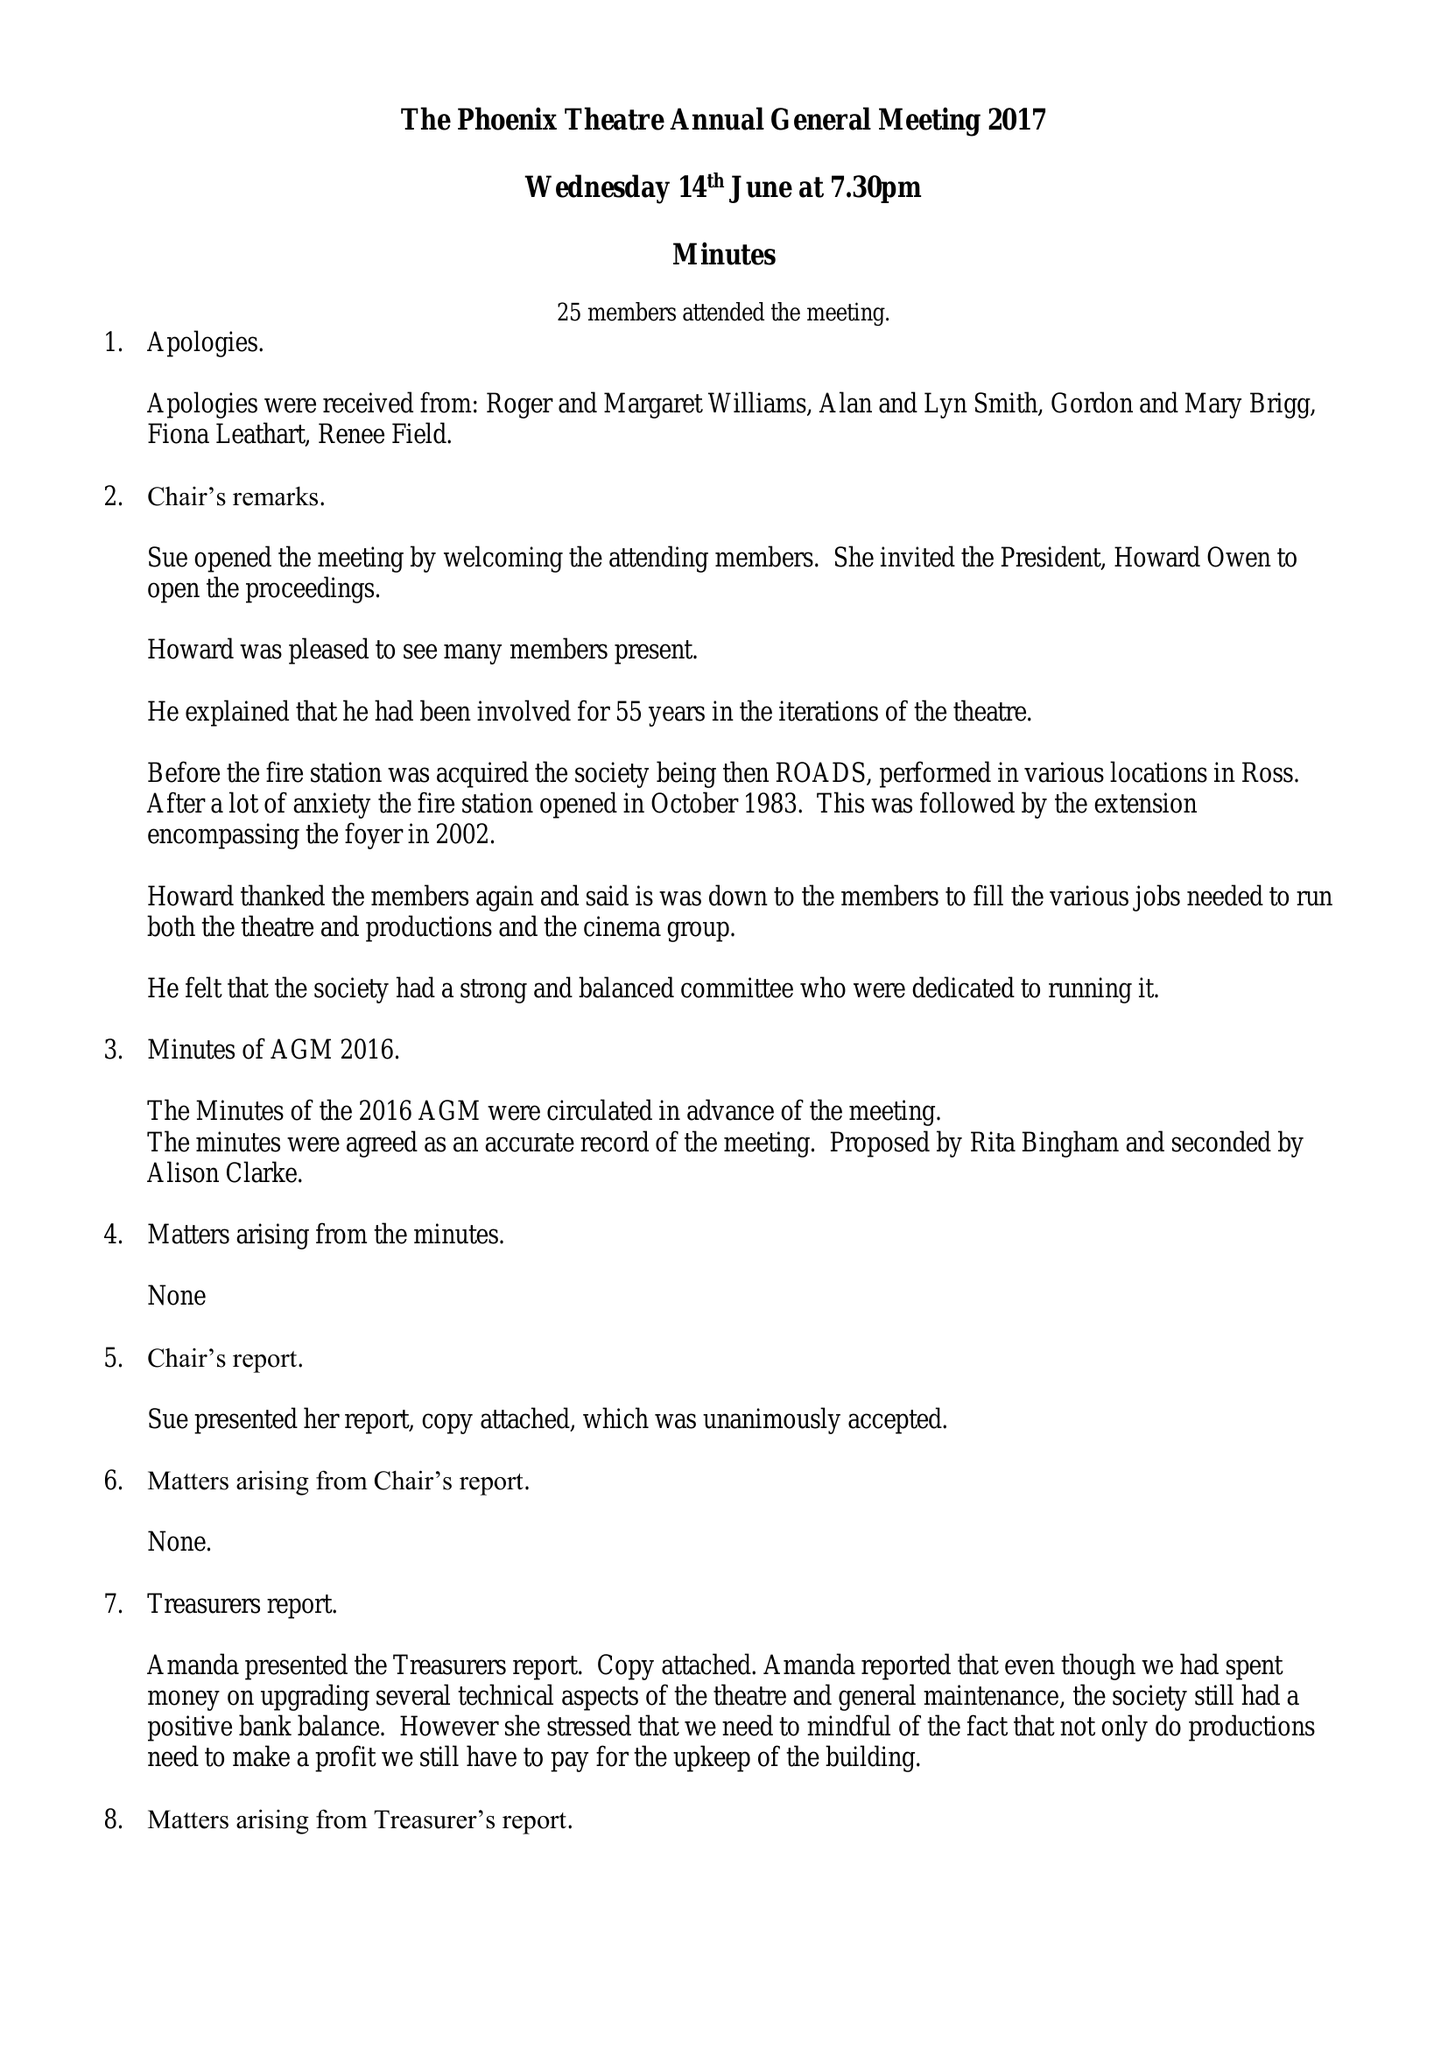What is the value for the report_date?
Answer the question using a single word or phrase. 2017-04-30 